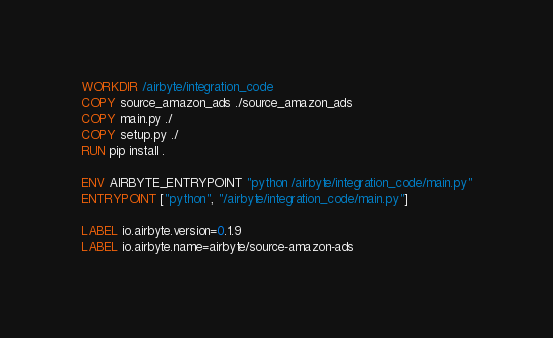<code> <loc_0><loc_0><loc_500><loc_500><_Dockerfile_>WORKDIR /airbyte/integration_code
COPY source_amazon_ads ./source_amazon_ads
COPY main.py ./
COPY setup.py ./
RUN pip install .

ENV AIRBYTE_ENTRYPOINT "python /airbyte/integration_code/main.py"
ENTRYPOINT ["python", "/airbyte/integration_code/main.py"]

LABEL io.airbyte.version=0.1.9
LABEL io.airbyte.name=airbyte/source-amazon-ads
</code> 